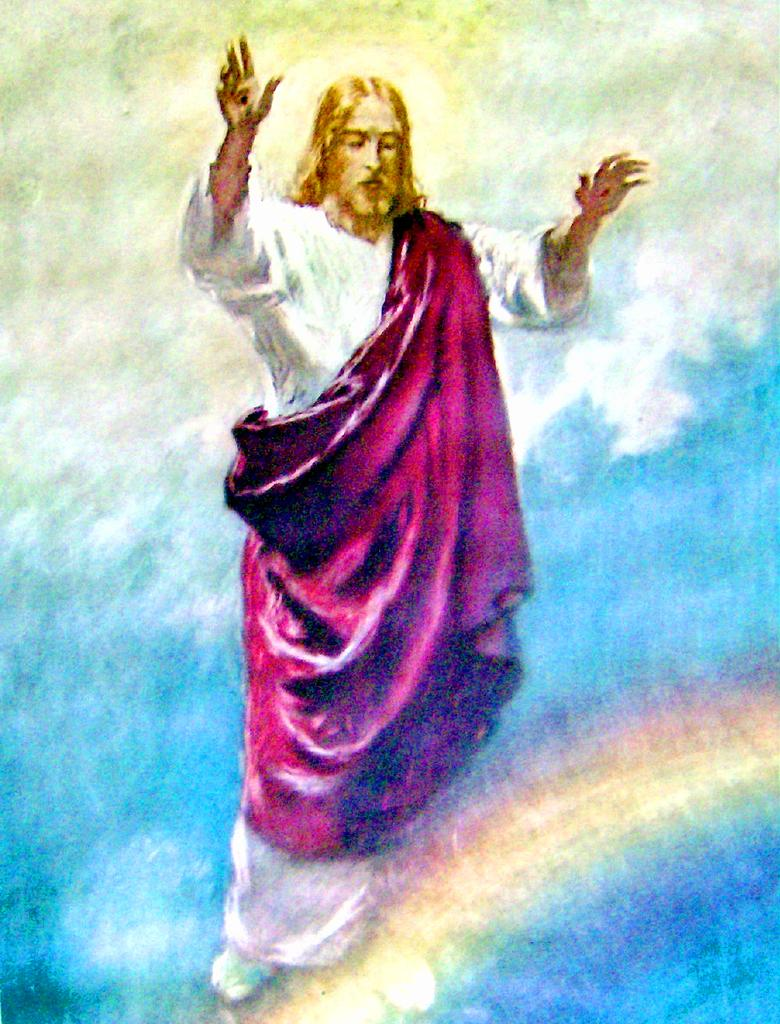What is the main subject of the image? There is a painting in the image. What does the painting depict? The painting depicts Jesus. How many grains of rice are scattered around the painting in the image? There is no rice present in the image, so it is not possible to determine the number of grains. 